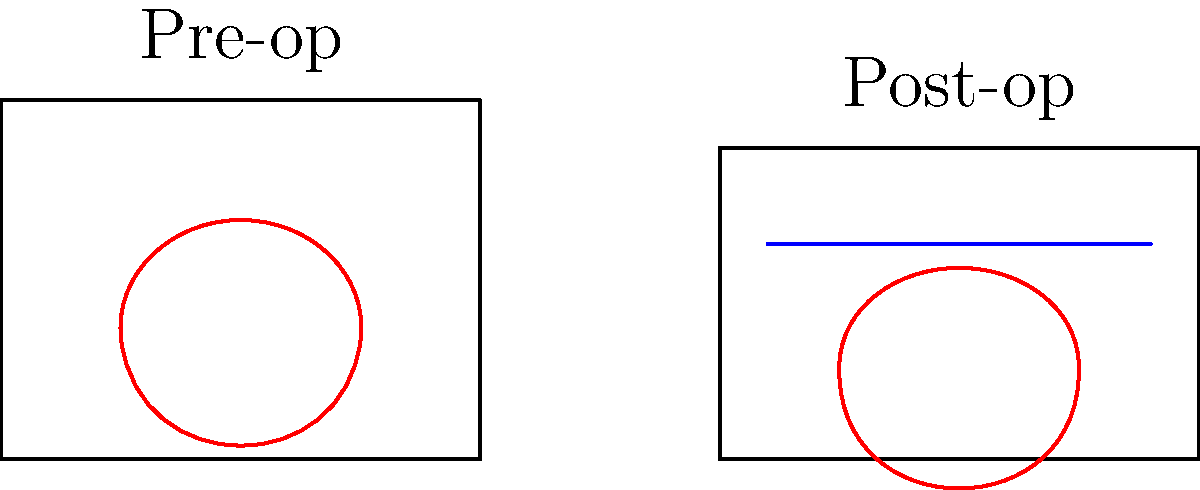Compare the pre-operative and post-operative chest X-ray images. What is the primary difference in cardiac silhouette congruence, and what factor contributes to this change? To answer this question, we need to analyze the two chest X-ray images step by step:

1. Pre-operative X-ray:
   - The cardiac silhouette (represented by the red outline) appears larger and more rounded.
   - The chest cavity (rectangular outline) is taller.

2. Post-operative X-ray:
   - The cardiac silhouette is smaller and less rounded.
   - The chest cavity is slightly shorter in height.
   - There is a blue line representing surgical wire, indicating a sternotomy has been performed.

3. Comparing the two images:
   - The primary difference in cardiac silhouette congruence is the reduction in size post-operatively.
   - This change is likely due to the cardiothoracic surgery performed, which often involves procedures that can alter the heart's size or shape.

4. Contributing factor:
   - The presence of the surgical wire (blue line) in the post-operative X-ray indicates that a sternotomy was performed.
   - Sternotomy is a common approach in cardiothoracic surgeries, allowing access to the heart and great vessels.
   - After surgery, the sternum is closed, which can slightly alter the chest cavity's dimensions and the heart's position.

5. Conclusion:
   - The primary difference in cardiac silhouette congruence is the reduced size post-operatively.
   - The contributing factor to this change is the cardiothoracic surgery performed, as evidenced by the sternotomy wire.
Answer: Reduced cardiac silhouette size post-operatively due to cardiothoracic surgery (sternotomy). 